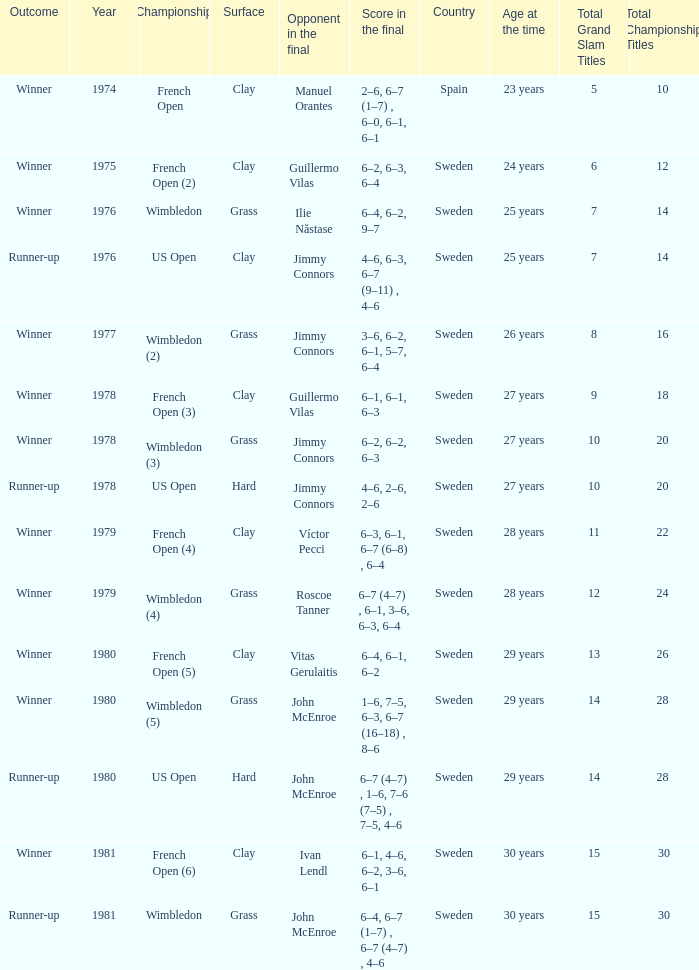What is every year where opponent in the final is John Mcenroe at Wimbledon? 1981.0. 